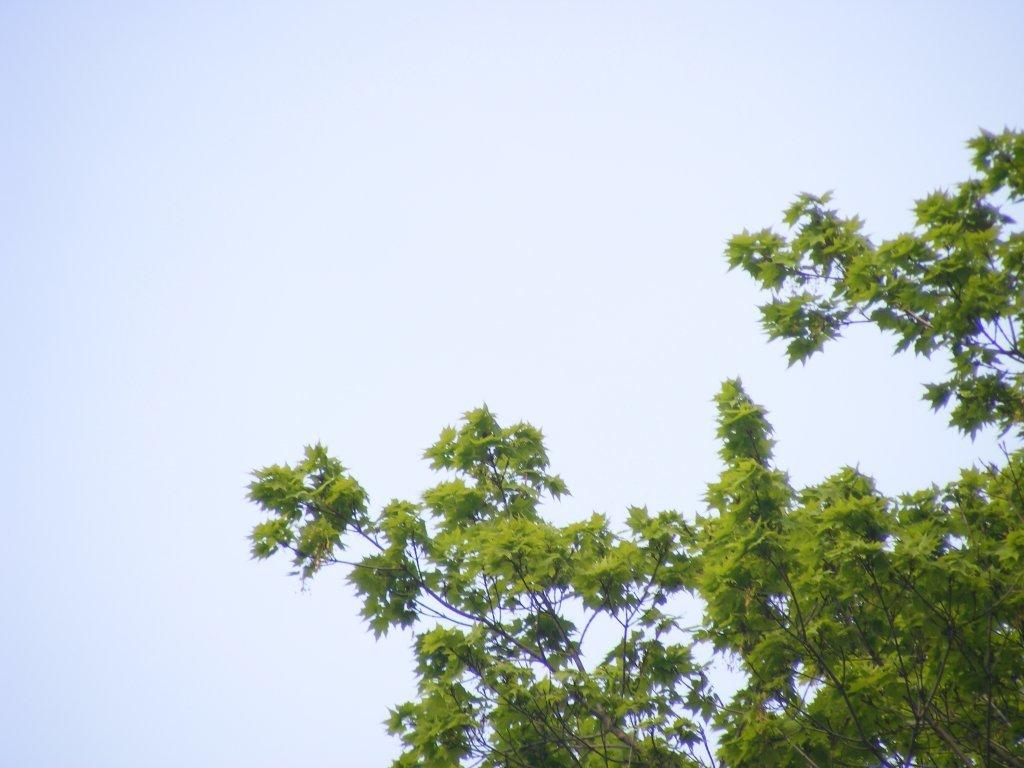What type of vegetation is present at the bottom of the image? There are leaves of a tree at the bottom of the image. What can be seen in the background of the image? There is a sky visible in the background of the image. What sign is displayed on the stem of the tree in the image? There is no sign present on the stem of the tree in the image. 